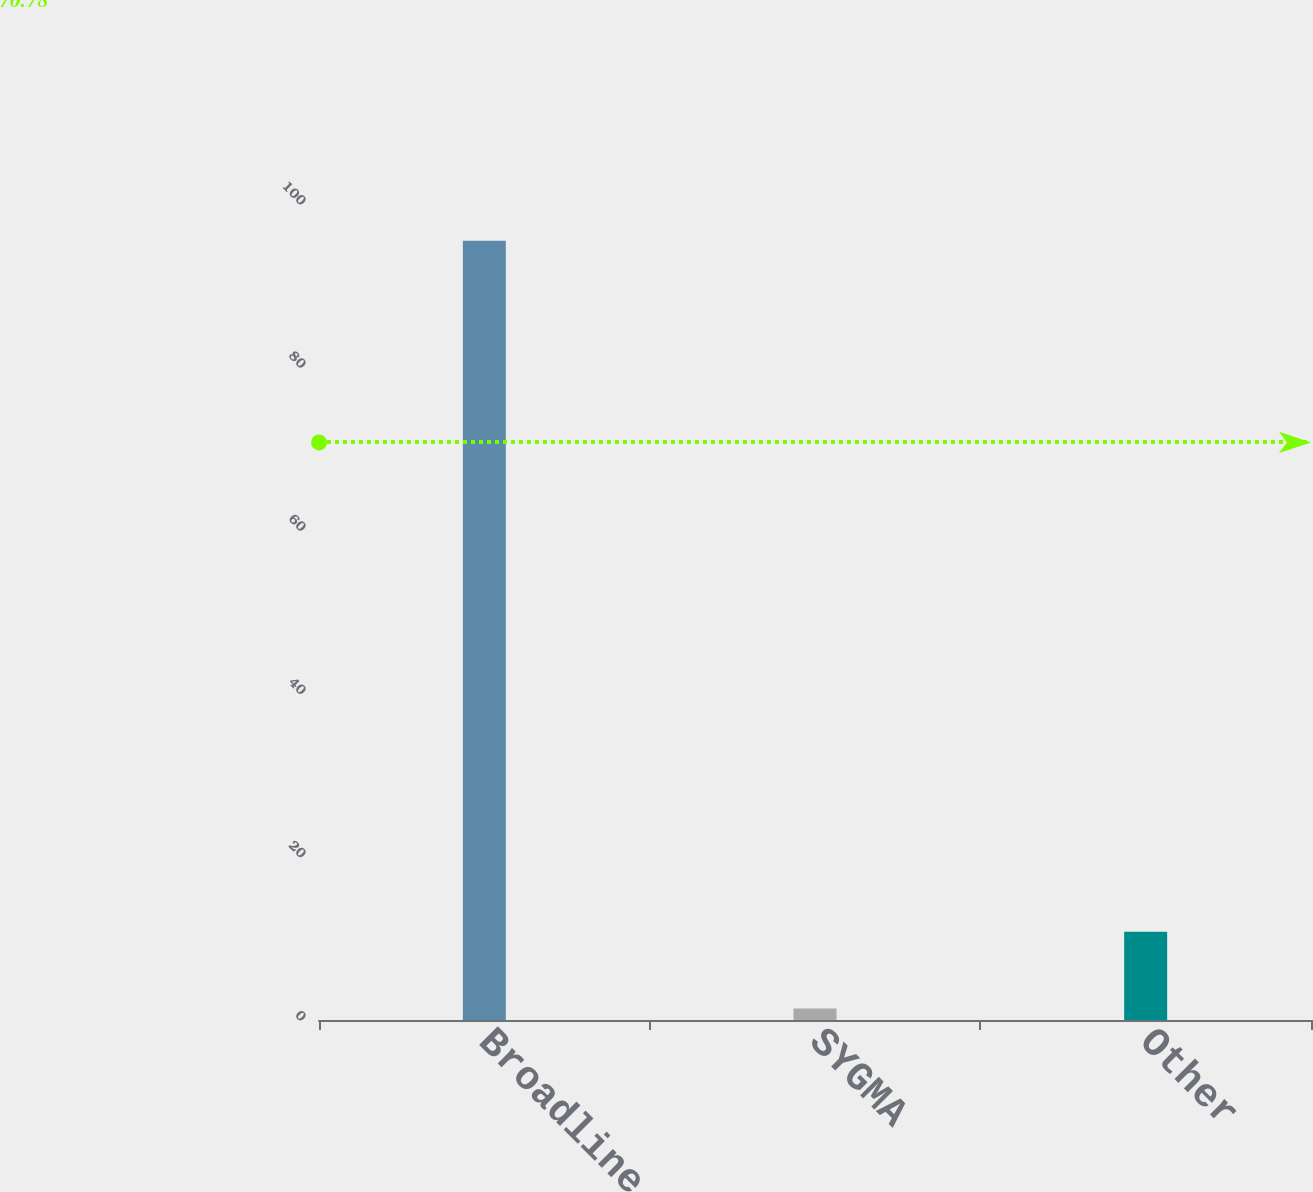Convert chart. <chart><loc_0><loc_0><loc_500><loc_500><bar_chart><fcel>Broadline<fcel>SYGMA<fcel>Other<nl><fcel>95.5<fcel>1.4<fcel>10.81<nl></chart> 